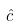Convert formula to latex. <formula><loc_0><loc_0><loc_500><loc_500>\hat { c }</formula> 